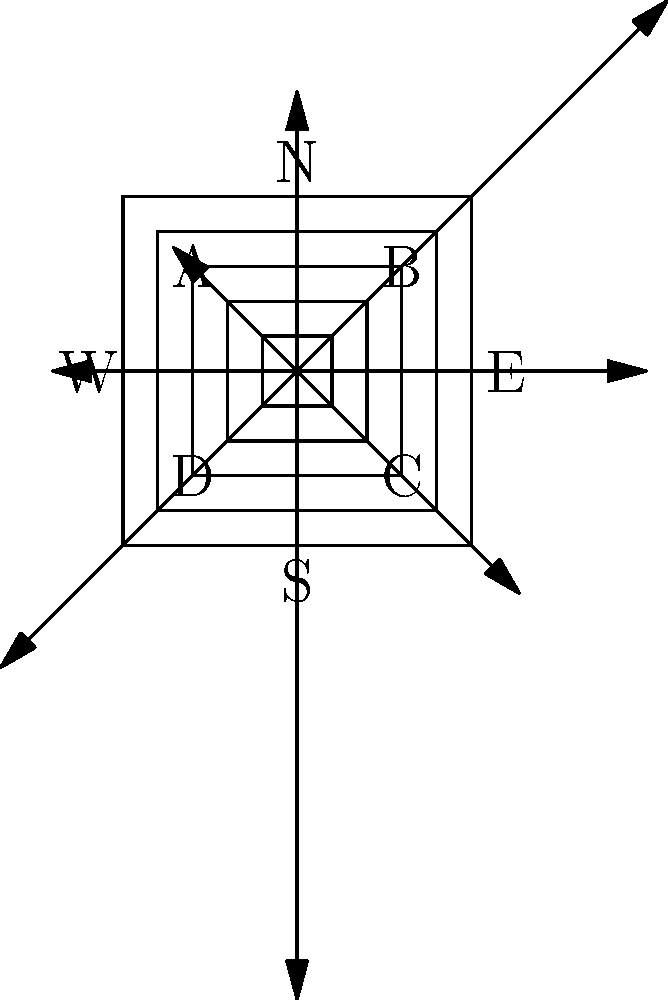Based on the topographical map and wind rose diagram provided, which location (A, B, C, or D) would be most suitable for a wind turbine installation, considering both elevation and predominant wind direction? To determine the most suitable location for a wind turbine installation, we need to consider both elevation and predominant wind direction:

1. Elevation analysis:
   - The topographical map shows contour lines, where each line represents a constant elevation.
   - The contour lines are concentric squares, indicating a hill or elevated area.
   - The center of the map has the highest elevation, decreasing towards the edges.

2. Wind direction analysis:
   - The wind rose diagram shows wind speeds and directions.
   - The longest arrow points towards the west, indicating that the predominant wind direction is from the east.
   - The second strongest wind comes from the north-northeast.

3. Location assessment:
   - Location A: High elevation, but not ideal for predominant wind from the east.
   - Location B: High elevation and well-positioned for the predominant easterly wind.
   - Location C: Lower elevation compared to A and B, but still good for easterly winds.
   - Location D: Lower elevation and not ideal for the predominant wind direction.

4. Optimal location selection:
   - Location B offers the best combination of high elevation and exposure to the predominant wind direction.
   - Higher elevation generally means stronger and more consistent wind speeds.
   - Being on the eastern edge of the elevated area, B will capture the strongest winds coming from the east.

Therefore, Location B is the most suitable for a wind turbine installation based on both elevation and predominant wind direction.
Answer: Location B 